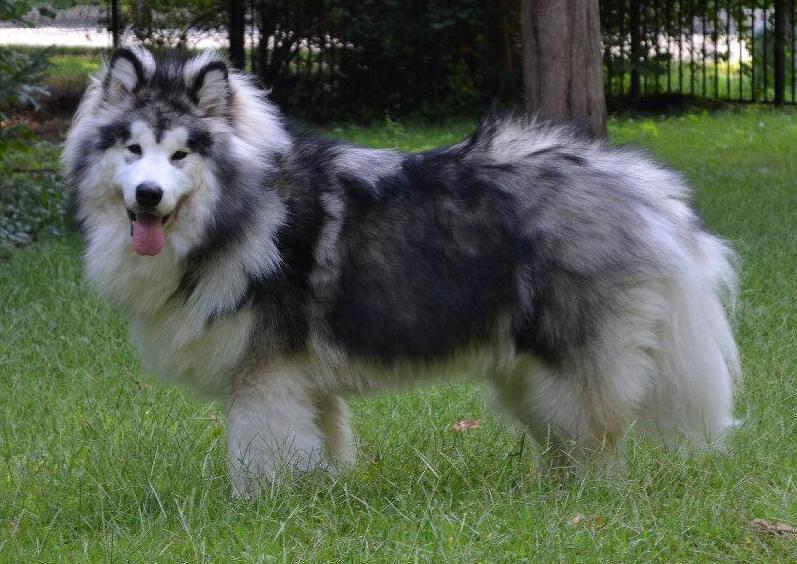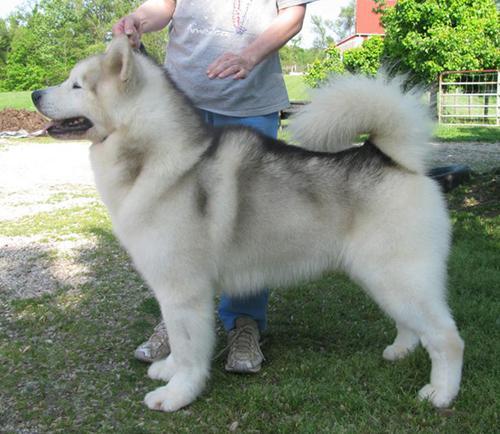The first image is the image on the left, the second image is the image on the right. Assess this claim about the two images: "A dog is standing next to a person.". Correct or not? Answer yes or no. Yes. The first image is the image on the left, the second image is the image on the right. Evaluate the accuracy of this statement regarding the images: "The left and right image contains the same number of dogs.". Is it true? Answer yes or no. Yes. 